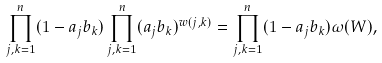<formula> <loc_0><loc_0><loc_500><loc_500>\prod _ { j , k = 1 } ^ { n } ( 1 - a _ { j } b _ { k } ) \prod _ { j , k = 1 } ^ { n } ( a _ { j } b _ { k } ) ^ { w ( j , k ) } = \prod _ { j , k = 1 } ^ { n } ( 1 - a _ { j } b _ { k } ) \omega ( W ) ,</formula> 